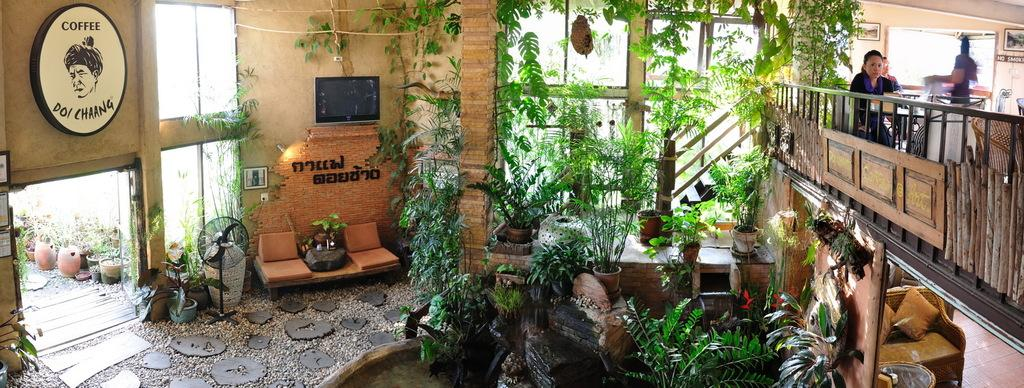What type of living organisms can be seen in the image? Plants are visible in the image. What electronic device can be seen in the image? There is a screen in the image. What appliance is present in the image? There is a fan in the image. What type of furniture is present in the image? There are frames, pots, a staircase, a wall, a railing, a sofa, pillows, chairs, and tables in the image. How many persons are involved in the industry depicted in the image? There is no industry depicted in the image. What type of street can be seen in the image? There is no street present in the image. What type of street can be seen in the image? There is no street present in the image. 